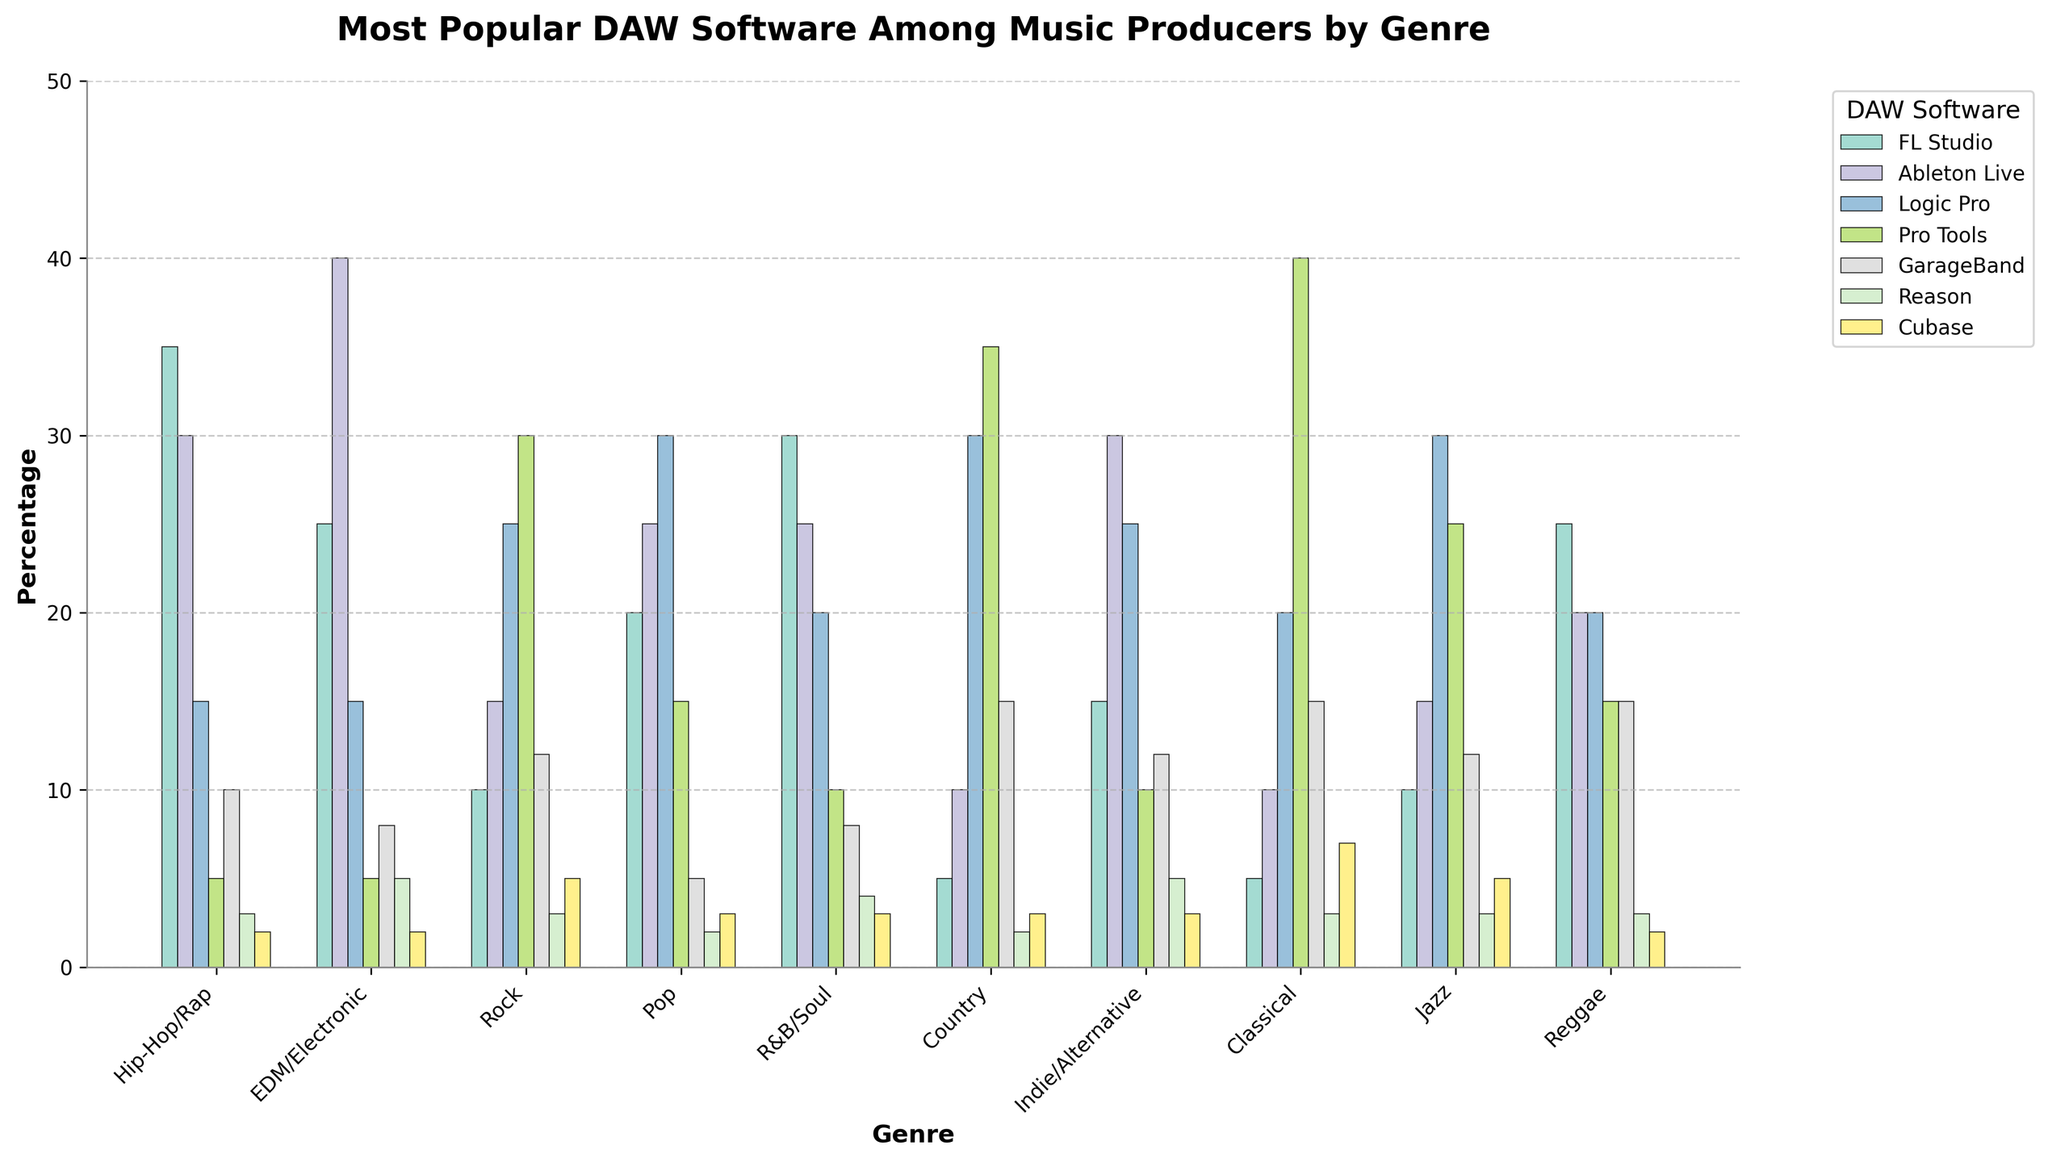What's the most popular DAW software among Hip-Hop/Rap producers? In the bar chart, the highest bar for the Hip-Hop/Rap genre indicates the most popular DAW software. FL Studio has the highest bar with 35%.
Answer: FL Studio Which DAW software is equally popular in Rock, Jazz, and Pop genres? By observing the bar heights in the bar chart, Logic Pro is equally popular in Rock, Jazz, and Pop genres, each with a height of 30%.
Answer: Logic Pro Between Pop and EDM/Electronic genres, which has more users for Ableton Live? Comparing the bar heights for Ableton Live in Pop and EDM/Electronic genres, EDM/Electronic has a taller bar (40%) than Pop (25%).
Answer: EDM/Electronic What is the combined popularity of FL Studio in Hip-Hop/Rap and EDM/Electronic genres? Sum the values of FL Studio in Hip-Hop/Rap (35%) and EDM/Electronic (25%). The combined popularity is 35% + 25% = 60%.
Answer: 60% Which genre shows the highest preference for Pro Tools? Look for the genre with the tallest bar for Pro Tools. Classical has the tallest bar with 40% for Pro Tools.
Answer: Classical Among Country and Classical genres, which has a higher combined preference for Logic Pro and GarageBand? Calculate the sum of Logic Pro and GarageBand for both genres: 
- Country: Logic Pro (30%) + GarageBand (15%) = 45%
- Classical: Logic Pro (20%) + GarageBand (15%) = 35%.
Country has a higher combined preference.
Answer: Country In terms of GarageBand, which two genres have the equal preference? Look for equal heights of the bars representing GarageBand. Rock and Jazz both have a preference of 12% for GarageBand.
Answer: Rock and Jazz Which DAW software is the least popular in all genres combined? Identifying the software with consistently low bars across all genres, Cubase has the least popularity.
Answer: Cubase What is the difference in popularity of FL Studio between Hip-Hop/Rap and Classical genres? Subtract the percentage of FL Studio in Classical (5%) from Hip-Hop/Rap (35%). The difference is 35% - 5% = 30%.
Answer: 30% Between R&B/Soul and Indie/Alternative genres, which has a higher average popularity of FL Studio and Reason combined? Calculate the average popularity for both genres:
- R&B/Soul: (FL Studio: 30% + Reason: 4%) / 2 = 17%
- Indie/Alternative: (FL Studio: 15% + Reason: 5%) / 2 = 10%.
R&B/Soul has a higher average.
Answer: R&B/Soul 